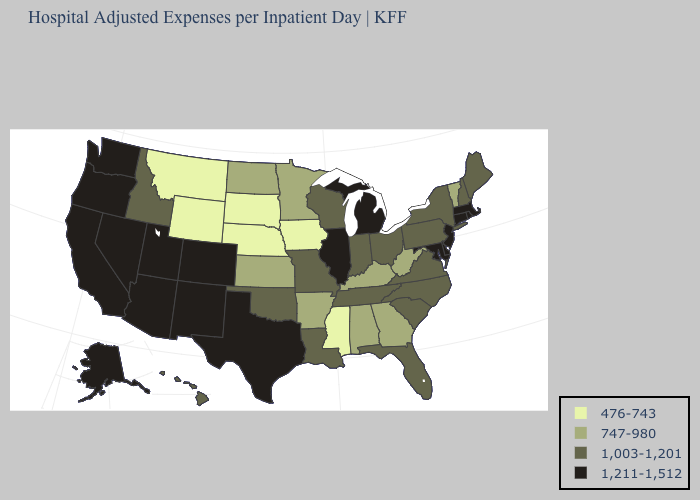What is the highest value in the West ?
Be succinct. 1,211-1,512. Among the states that border New Hampshire , which have the highest value?
Write a very short answer. Massachusetts. What is the highest value in the South ?
Short answer required. 1,211-1,512. What is the lowest value in the USA?
Write a very short answer. 476-743. What is the highest value in the West ?
Be succinct. 1,211-1,512. Name the states that have a value in the range 1,211-1,512?
Concise answer only. Alaska, Arizona, California, Colorado, Connecticut, Delaware, Illinois, Maryland, Massachusetts, Michigan, Nevada, New Jersey, New Mexico, Oregon, Rhode Island, Texas, Utah, Washington. Does Florida have the same value as Kentucky?
Be succinct. No. Which states have the lowest value in the MidWest?
Give a very brief answer. Iowa, Nebraska, South Dakota. Which states have the lowest value in the South?
Write a very short answer. Mississippi. What is the highest value in states that border Maryland?
Concise answer only. 1,211-1,512. What is the value of Indiana?
Concise answer only. 1,003-1,201. What is the value of Nevada?
Answer briefly. 1,211-1,512. What is the value of West Virginia?
Answer briefly. 747-980. Does New Mexico have the lowest value in the USA?
Answer briefly. No. 